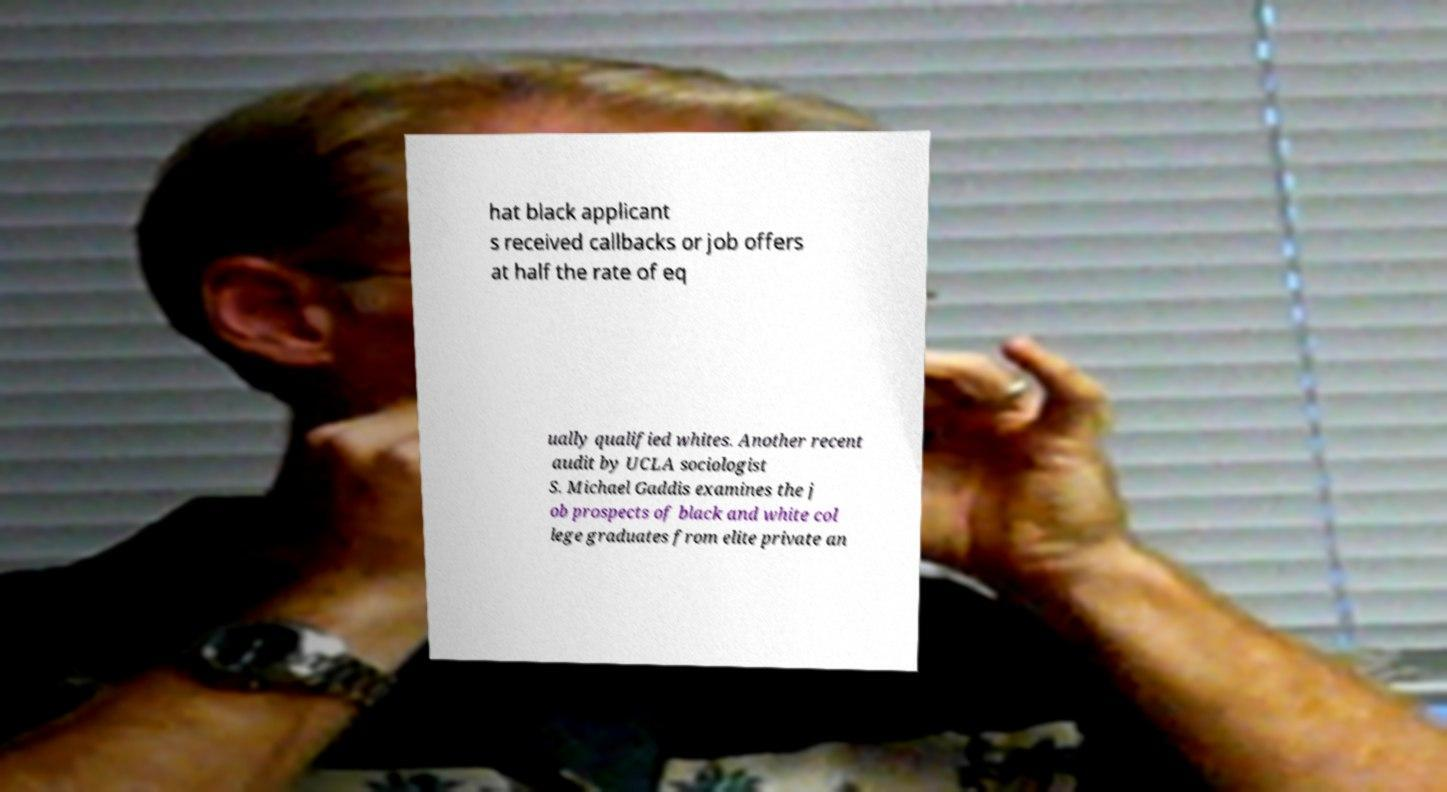Can you accurately transcribe the text from the provided image for me? hat black applicant s received callbacks or job offers at half the rate of eq ually qualified whites. Another recent audit by UCLA sociologist S. Michael Gaddis examines the j ob prospects of black and white col lege graduates from elite private an 